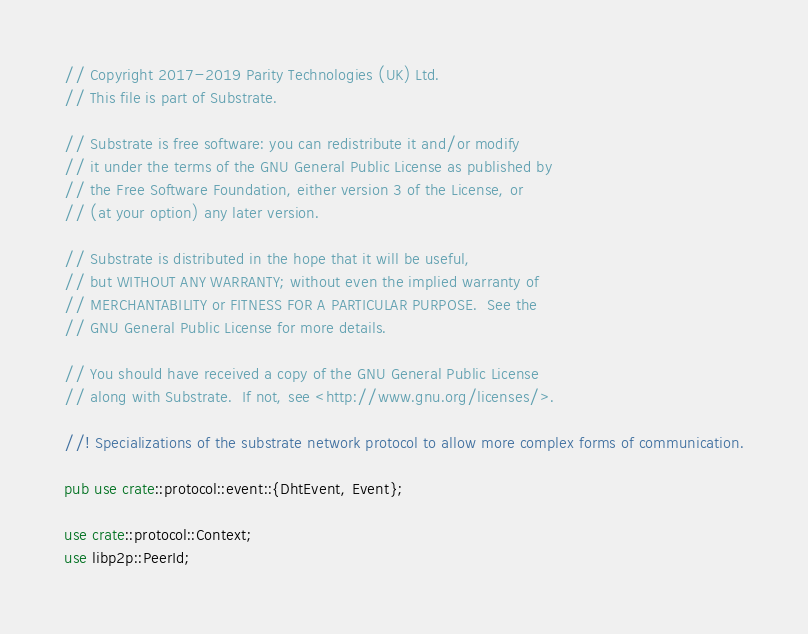Convert code to text. <code><loc_0><loc_0><loc_500><loc_500><_Rust_>// Copyright 2017-2019 Parity Technologies (UK) Ltd.
// This file is part of Substrate.

// Substrate is free software: you can redistribute it and/or modify
// it under the terms of the GNU General Public License as published by
// the Free Software Foundation, either version 3 of the License, or
// (at your option) any later version.

// Substrate is distributed in the hope that it will be useful,
// but WITHOUT ANY WARRANTY; without even the implied warranty of
// MERCHANTABILITY or FITNESS FOR A PARTICULAR PURPOSE.  See the
// GNU General Public License for more details.

// You should have received a copy of the GNU General Public License
// along with Substrate.  If not, see <http://www.gnu.org/licenses/>.

//! Specializations of the substrate network protocol to allow more complex forms of communication.

pub use crate::protocol::event::{DhtEvent, Event};

use crate::protocol::Context;
use libp2p::PeerId;</code> 